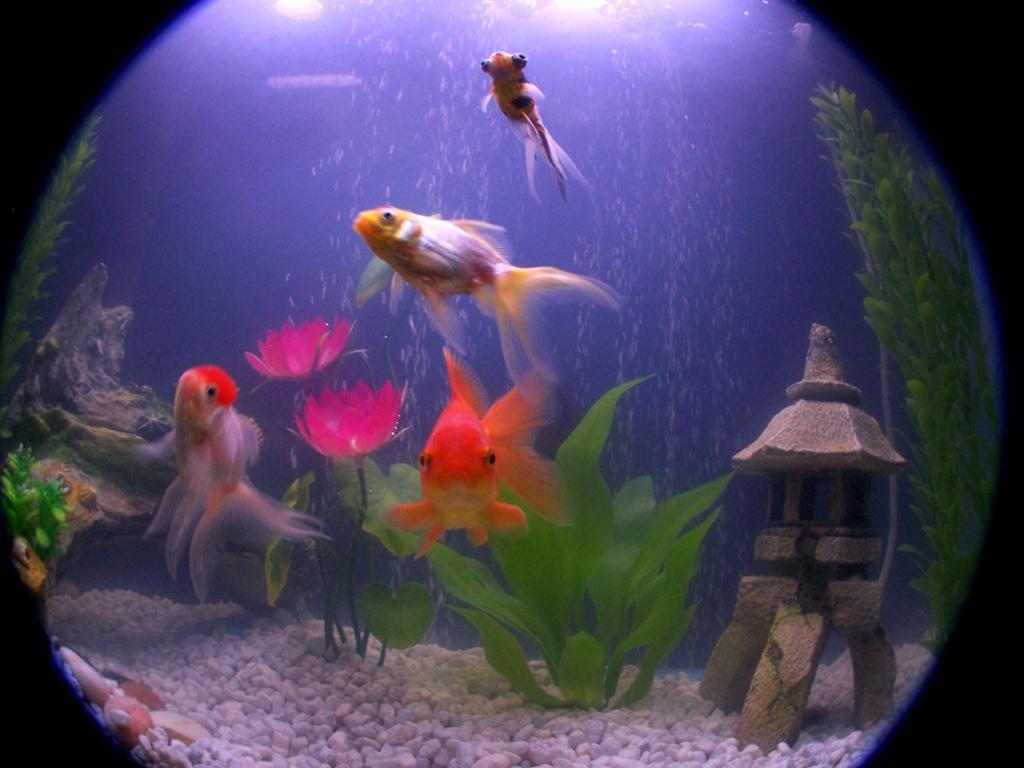Could you give a brief overview of what you see in this image? Here we can see fishes in the water,flowers,plants,small wooden log,small stones and at the top there are lights. This is an edited image in spherical shape. 